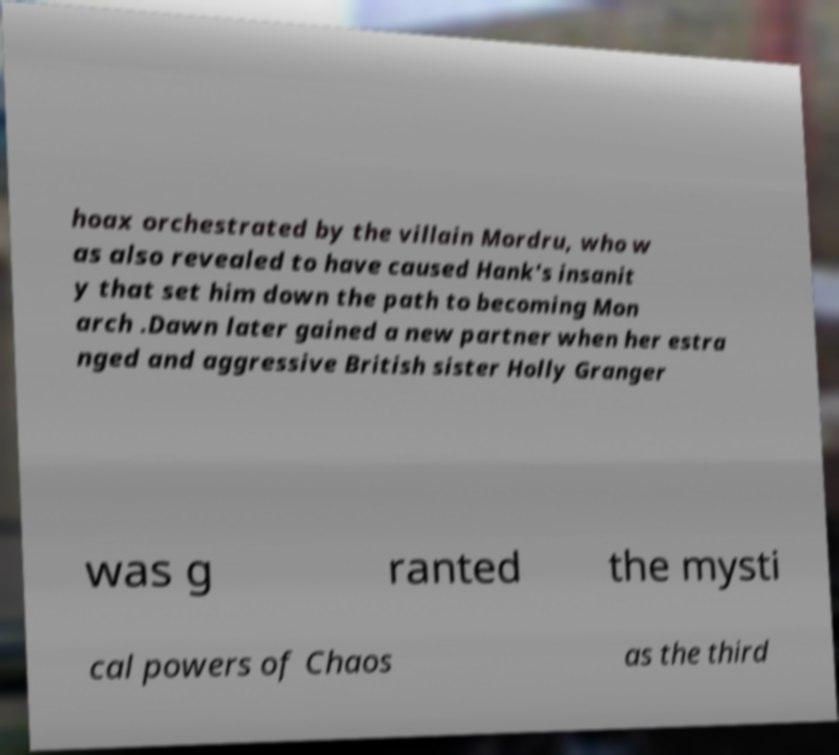Please identify and transcribe the text found in this image. hoax orchestrated by the villain Mordru, who w as also revealed to have caused Hank's insanit y that set him down the path to becoming Mon arch .Dawn later gained a new partner when her estra nged and aggressive British sister Holly Granger was g ranted the mysti cal powers of Chaos as the third 